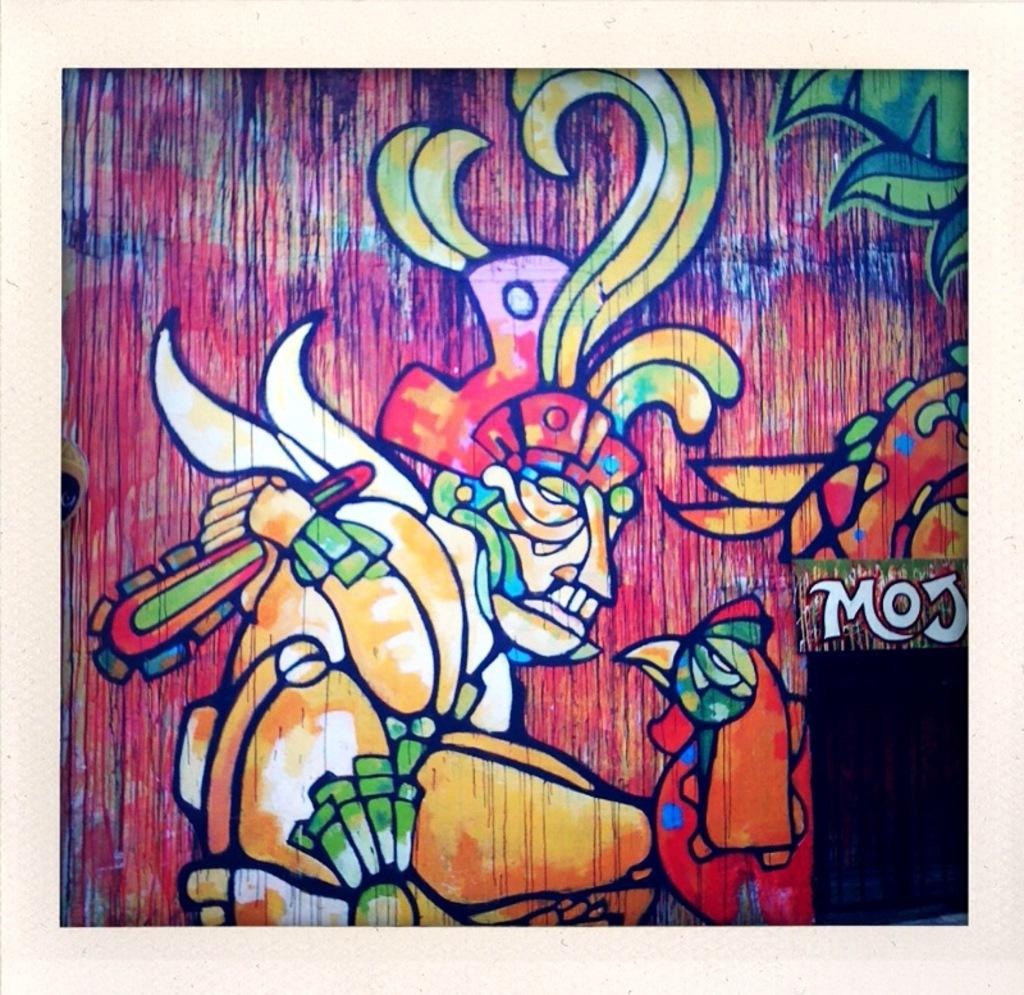Provide a one-sentence caption for the provided image. A colorful painting that includes a person with a headpiece on and the letters MOJ. 